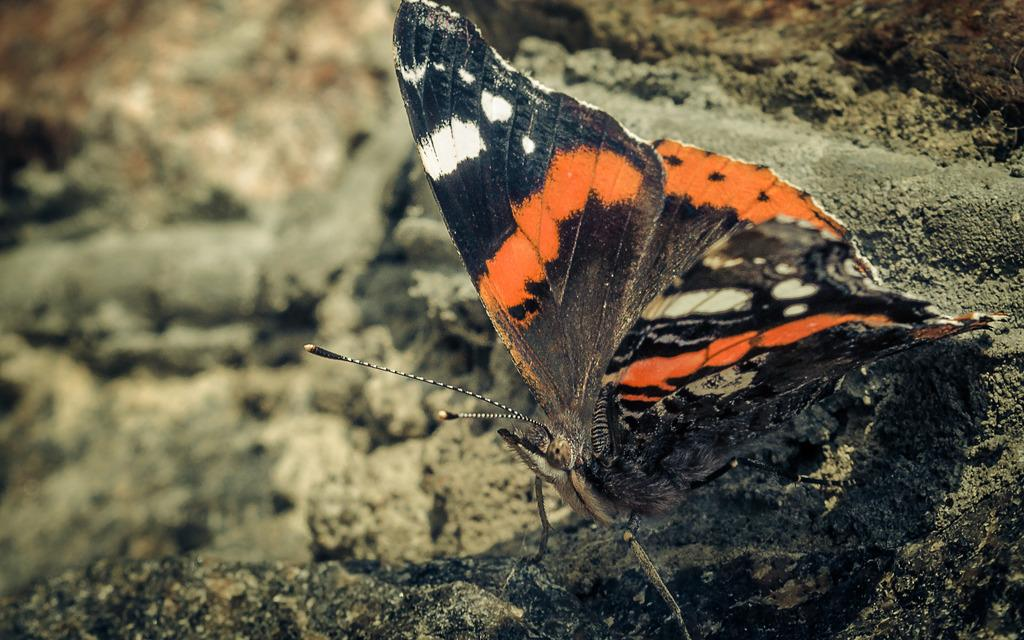What is the main subject of the image? There is a butterfly in the image. Can you describe the colors of the butterfly? The butterfly has black, white, and orange colors. What can be observed about the background of the image? The background of the image is blurred. What type of dress is the butterfly wearing in the image? Butterflies do not wear dresses, as they are insects and not human beings. 